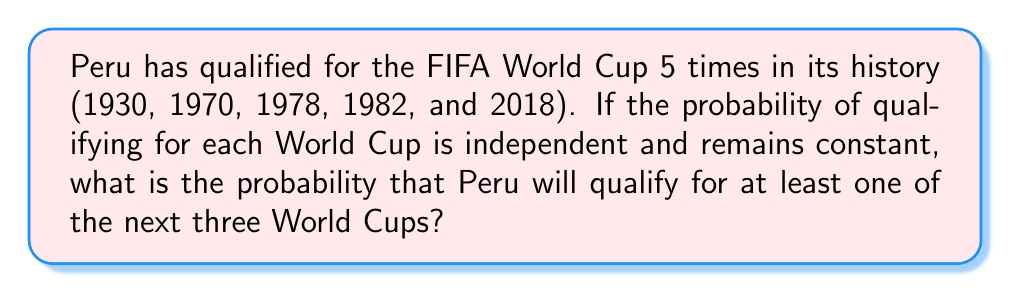Could you help me with this problem? Let's approach this step-by-step:

1) First, we need to calculate the probability of Peru qualifying for a single World Cup. Given the information:
   - Total World Cups held: 22 (from 1930 to 2022)
   - Times Peru qualified: 5
   
   Probability of qualifying for a single World Cup = $\frac{5}{22} \approx 0.2273$

2) Let's call the probability of qualifying $p = 0.2273$

3) The probability of not qualifying for a single World Cup is therefore $1 - p = 0.7727$

4) For Peru to not qualify for any of the next three World Cups, they would need to fail to qualify three times in a row. The probability of this is:

   $$(1-p)^3 = 0.7727^3 \approx 0.4612$$

5) Therefore, the probability of qualifying for at least one of the next three World Cups is the opposite of not qualifying for any:

   $$1 - (1-p)^3 = 1 - 0.7727^3 \approx 1 - 0.4612 = 0.5388$$

6) We can also express this using the formula for the probability of at least one success in $n$ independent trials:

   $$P(\text{at least one success}) = 1 - (1-p)^n$$

   Where $n = 3$ (next three World Cups) and $p = 0.2273$
Answer: The probability that Peru will qualify for at least one of the next three World Cups is approximately 0.5388 or 53.88%. 